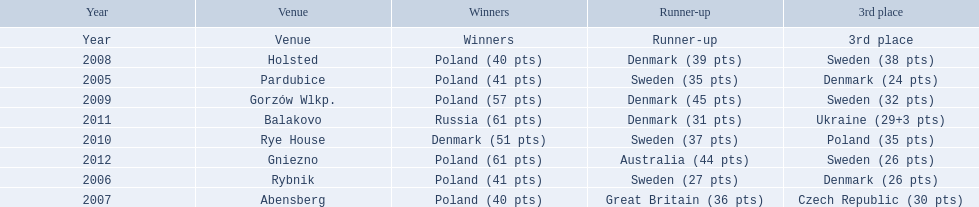Could you parse the entire table as a dict? {'header': ['Year', 'Venue', 'Winners', 'Runner-up', '3rd place'], 'rows': [['Year', 'Venue', 'Winners', 'Runner-up', '3rd place'], ['2008', 'Holsted', 'Poland (40 pts)', 'Denmark (39 pts)', 'Sweden (38 pts)'], ['2005', 'Pardubice', 'Poland (41 pts)', 'Sweden (35 pts)', 'Denmark (24 pts)'], ['2009', 'Gorzów Wlkp.', 'Poland (57 pts)', 'Denmark (45 pts)', 'Sweden (32 pts)'], ['2011', 'Balakovo', 'Russia (61 pts)', 'Denmark (31 pts)', 'Ukraine (29+3 pts)'], ['2010', 'Rye House', 'Denmark (51 pts)', 'Sweden (37 pts)', 'Poland (35 pts)'], ['2012', 'Gniezno', 'Poland (61 pts)', 'Australia (44 pts)', 'Sweden (26 pts)'], ['2006', 'Rybnik', 'Poland (41 pts)', 'Sweden (27 pts)', 'Denmark (26 pts)'], ['2007', 'Abensberg', 'Poland (40 pts)', 'Great Britain (36 pts)', 'Czech Republic (30 pts)']]} After enjoying five consecutive victories at the team speedway junior world championship poland was finally unseated in what year? 2010. In that year, what teams placed first through third? Denmark (51 pts), Sweden (37 pts), Poland (35 pts). Which of those positions did poland specifically place in? 3rd place. 